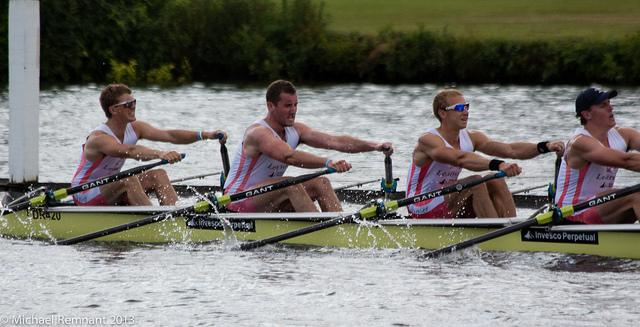Who are these people to each other? teammates 